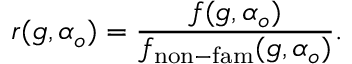Convert formula to latex. <formula><loc_0><loc_0><loc_500><loc_500>r ( g , \alpha _ { o } ) = \frac { f ( g , \alpha _ { o } ) } { f _ { n o n - f a m } ( g , \alpha _ { o } ) } .</formula> 